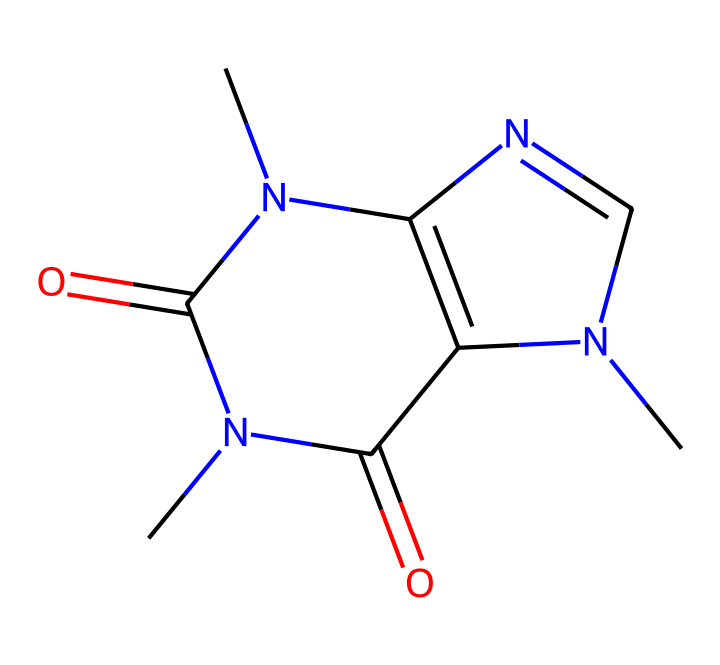What is the molecular formula of caffeine? By analyzing the SMILES representation, we can determine the individual atoms present in the compound. Each letter in the SMILES string corresponds to an atom (C for carbon, N for nitrogen, and O for oxygen). Counting the atoms yields 8 carbons, 10 hydrogens, 4 nitrogens, and 2 oxygens, resulting in the molecular formula C8H10N4O2.
Answer: C8H10N4O2 How many nitrogen atoms are in the caffeine structure? From the SMILES representation, we can easily identify the 'N' characters indicating nitrogen atoms. Counting these provides a total of 4 nitrogen atoms present in the structure of caffeine.
Answer: 4 What type of compound is caffeine classified as? Caffeine is classified as an alkaloid due to its nitrogen-containing structure which typically occurs in plants and has pharmacological effects. Recognizing the functional groups, particularly the presence of multiple nitrogen atoms, allows us to categorize it as an alkaloid.
Answer: alkaloid What is the number of rings in the caffeine structure? The SMILES indicates fused rings through the structure (noted by the sequential numbering of 'N' and 'C'). By determining how many cyclic components are present and identifying the interconnected nature of these rings, we find that caffeine contains 2 rings.
Answer: 2 Does caffeine have any keto groups? In the SMILES representation, the presence of the 'C(=O)' notation indicates carbon atoms double-bonded to oxygen atoms, which identifies keto groups in the structure. In caffeine, there are 2 instances of 'C(=O)', confirming the presence of keto groups.
Answer: 2 